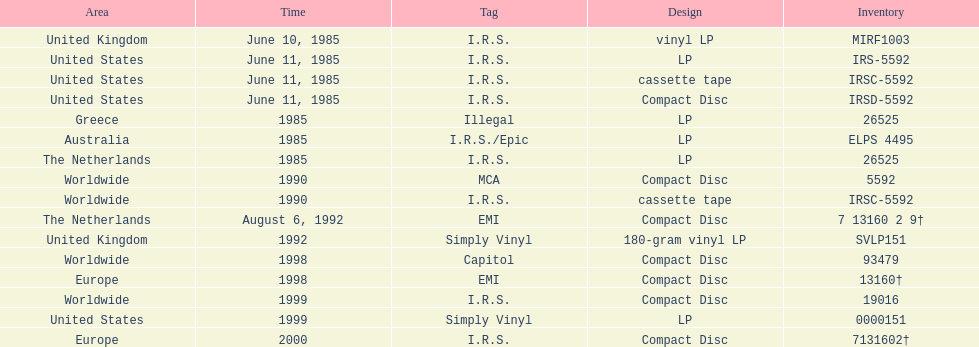What was the date of the first vinyl lp release? June 10, 1985. 